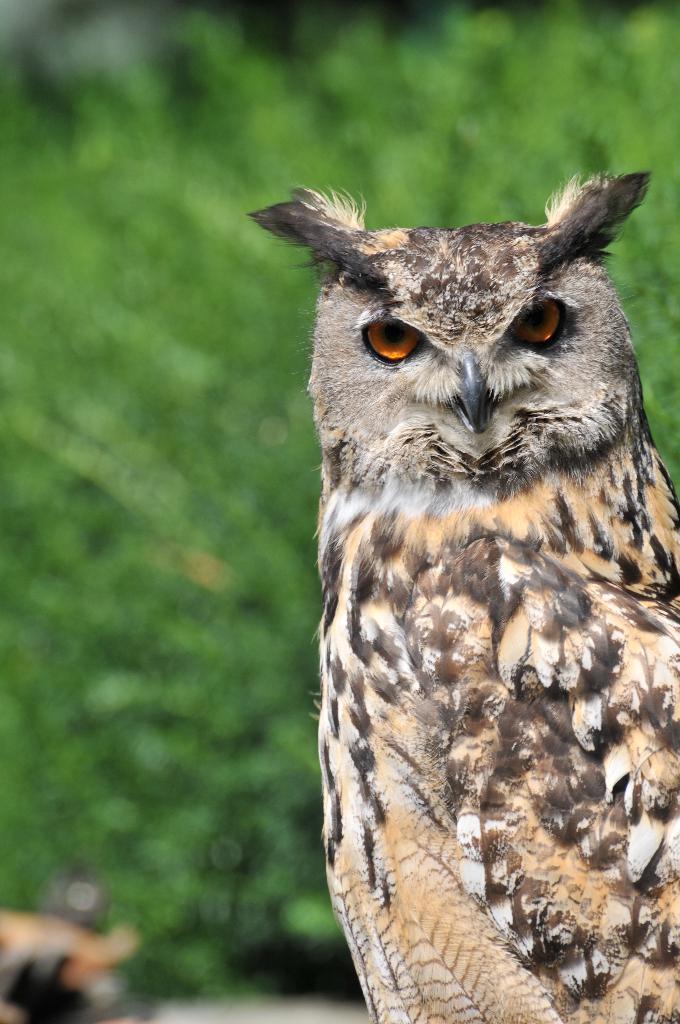Please provide a concise description of this image. In this picture there is an owl. In the back we can see the plants. 